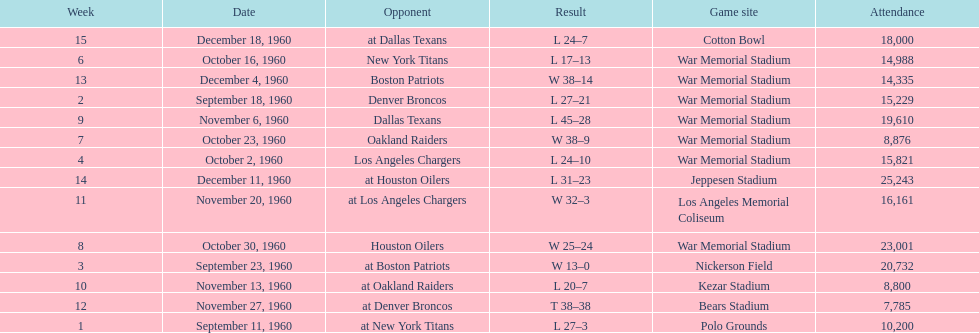How many games had an attendance of 10,000 at most? 11. Help me parse the entirety of this table. {'header': ['Week', 'Date', 'Opponent', 'Result', 'Game site', 'Attendance'], 'rows': [['15', 'December 18, 1960', 'at Dallas Texans', 'L 24–7', 'Cotton Bowl', '18,000'], ['6', 'October 16, 1960', 'New York Titans', 'L 17–13', 'War Memorial Stadium', '14,988'], ['13', 'December 4, 1960', 'Boston Patriots', 'W 38–14', 'War Memorial Stadium', '14,335'], ['2', 'September 18, 1960', 'Denver Broncos', 'L 27–21', 'War Memorial Stadium', '15,229'], ['9', 'November 6, 1960', 'Dallas Texans', 'L 45–28', 'War Memorial Stadium', '19,610'], ['7', 'October 23, 1960', 'Oakland Raiders', 'W 38–9', 'War Memorial Stadium', '8,876'], ['4', 'October 2, 1960', 'Los Angeles Chargers', 'L 24–10', 'War Memorial Stadium', '15,821'], ['14', 'December 11, 1960', 'at Houston Oilers', 'L 31–23', 'Jeppesen Stadium', '25,243'], ['11', 'November 20, 1960', 'at Los Angeles Chargers', 'W 32–3', 'Los Angeles Memorial Coliseum', '16,161'], ['8', 'October 30, 1960', 'Houston Oilers', 'W 25–24', 'War Memorial Stadium', '23,001'], ['3', 'September 23, 1960', 'at Boston Patriots', 'W 13–0', 'Nickerson Field', '20,732'], ['10', 'November 13, 1960', 'at Oakland Raiders', 'L 20–7', 'Kezar Stadium', '8,800'], ['12', 'November 27, 1960', 'at Denver Broncos', 'T 38–38', 'Bears Stadium', '7,785'], ['1', 'September 11, 1960', 'at New York Titans', 'L 27–3', 'Polo Grounds', '10,200']]} 